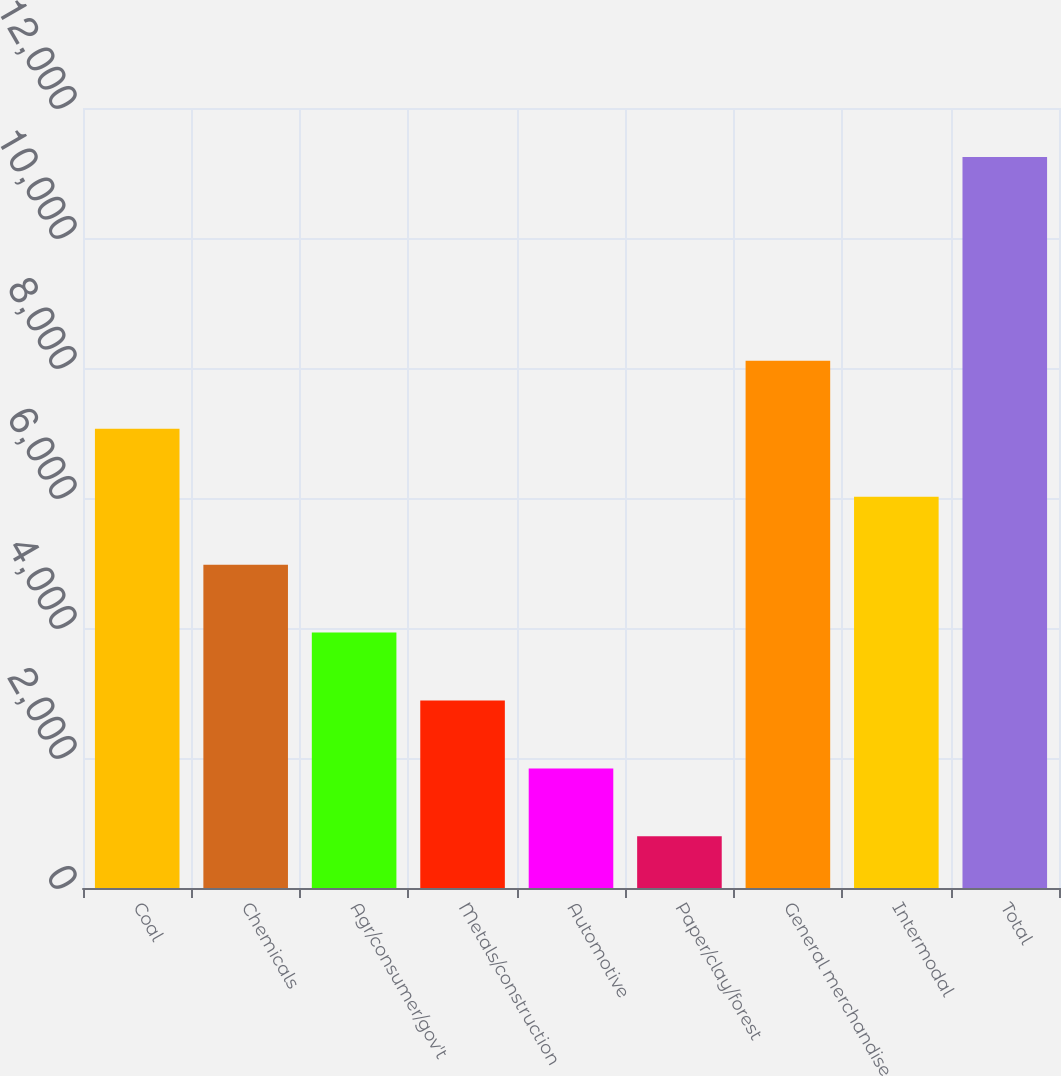Convert chart. <chart><loc_0><loc_0><loc_500><loc_500><bar_chart><fcel>Coal<fcel>Chemicals<fcel>Agr/consumer/gov't<fcel>Metals/construction<fcel>Automotive<fcel>Paper/clay/forest<fcel>General merchandise<fcel>Intermodal<fcel>Total<nl><fcel>7065<fcel>4975<fcel>3930<fcel>2885<fcel>1840<fcel>795<fcel>8110<fcel>6020<fcel>11245<nl></chart> 